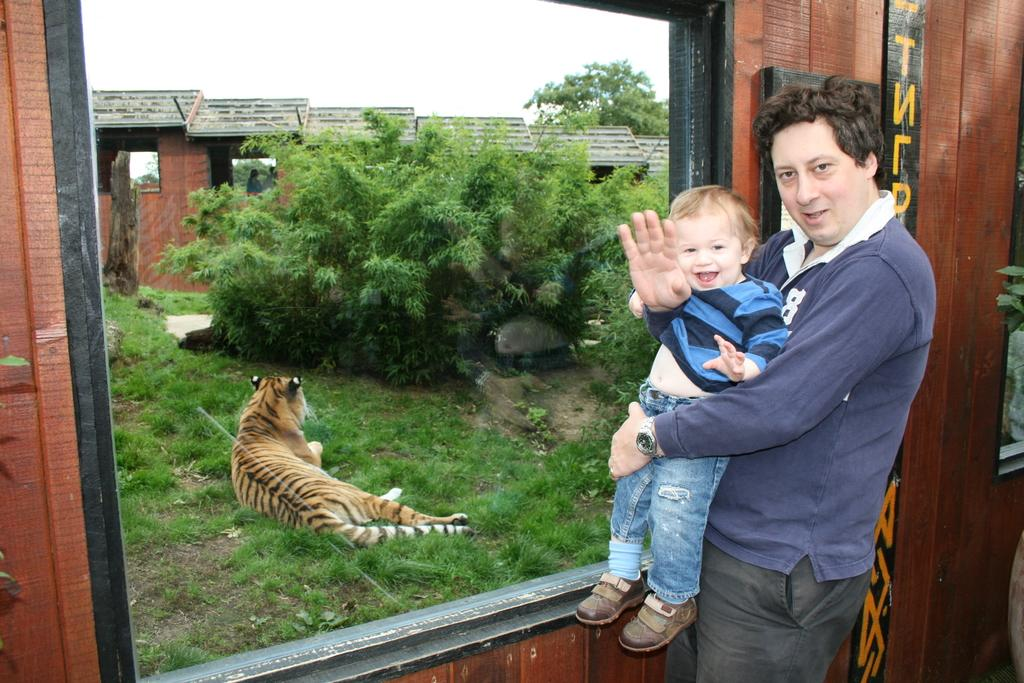What is the man in the image holding? The man is holding a baby. What object can be seen in the image besides the man and the baby? There is a glass in the image. What can be seen through the glass? A tiger, trees, and a building can be seen through the glass. What type of spade is being used to dig in the aftermath of the tiger's escape? There is no spade or any indication of a tiger's escape in the image. 